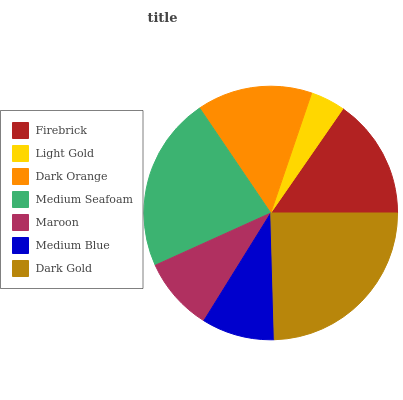Is Light Gold the minimum?
Answer yes or no. Yes. Is Dark Gold the maximum?
Answer yes or no. Yes. Is Dark Orange the minimum?
Answer yes or no. No. Is Dark Orange the maximum?
Answer yes or no. No. Is Dark Orange greater than Light Gold?
Answer yes or no. Yes. Is Light Gold less than Dark Orange?
Answer yes or no. Yes. Is Light Gold greater than Dark Orange?
Answer yes or no. No. Is Dark Orange less than Light Gold?
Answer yes or no. No. Is Dark Orange the high median?
Answer yes or no. Yes. Is Dark Orange the low median?
Answer yes or no. Yes. Is Medium Seafoam the high median?
Answer yes or no. No. Is Medium Seafoam the low median?
Answer yes or no. No. 